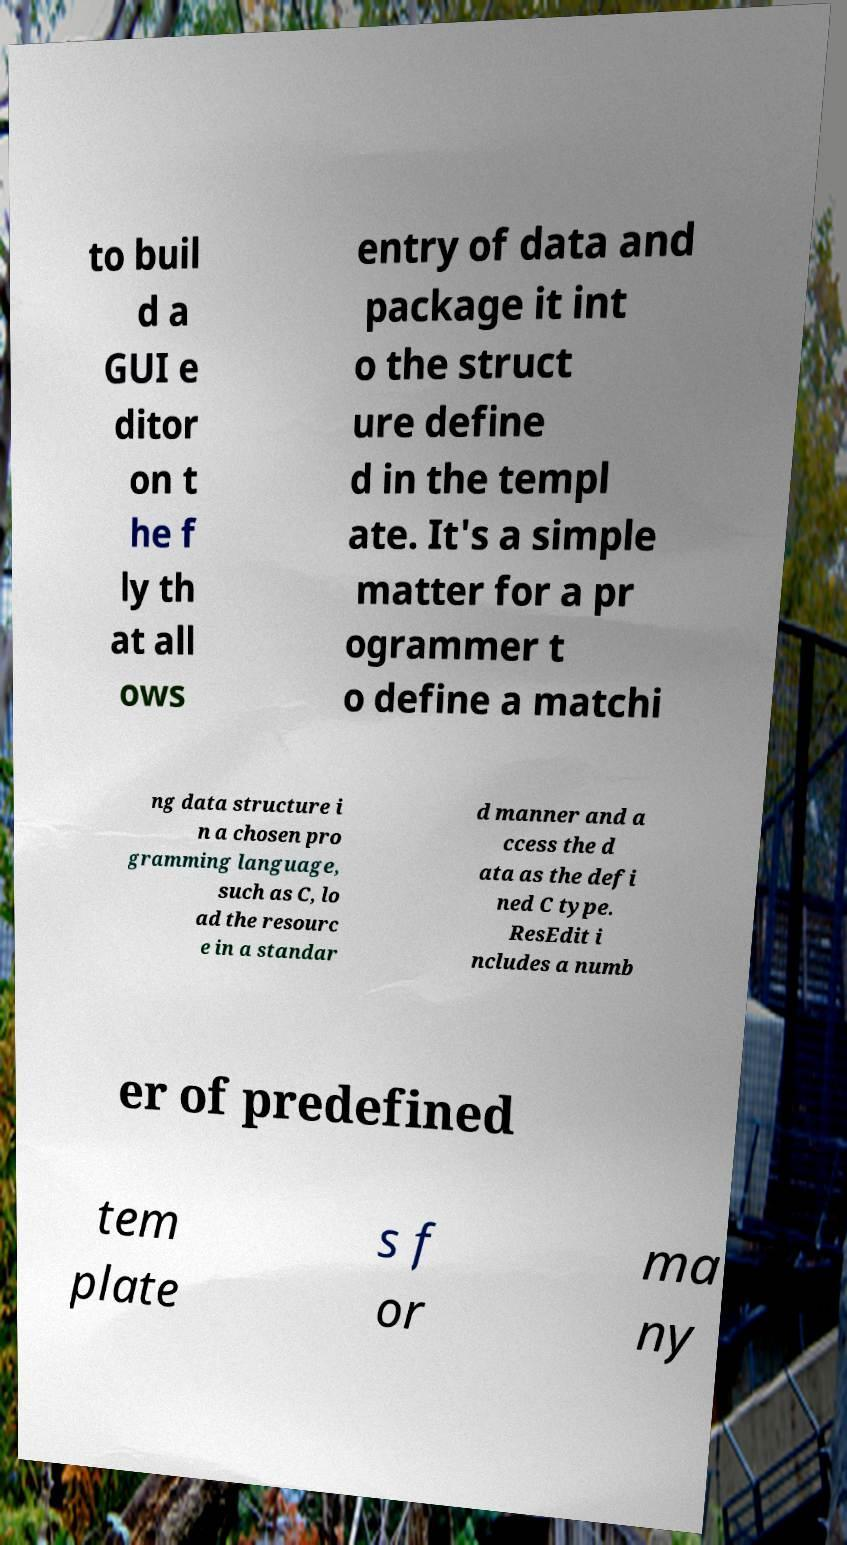Could you extract and type out the text from this image? to buil d a GUI e ditor on t he f ly th at all ows entry of data and package it int o the struct ure define d in the templ ate. It's a simple matter for a pr ogrammer t o define a matchi ng data structure i n a chosen pro gramming language, such as C, lo ad the resourc e in a standar d manner and a ccess the d ata as the defi ned C type. ResEdit i ncludes a numb er of predefined tem plate s f or ma ny 